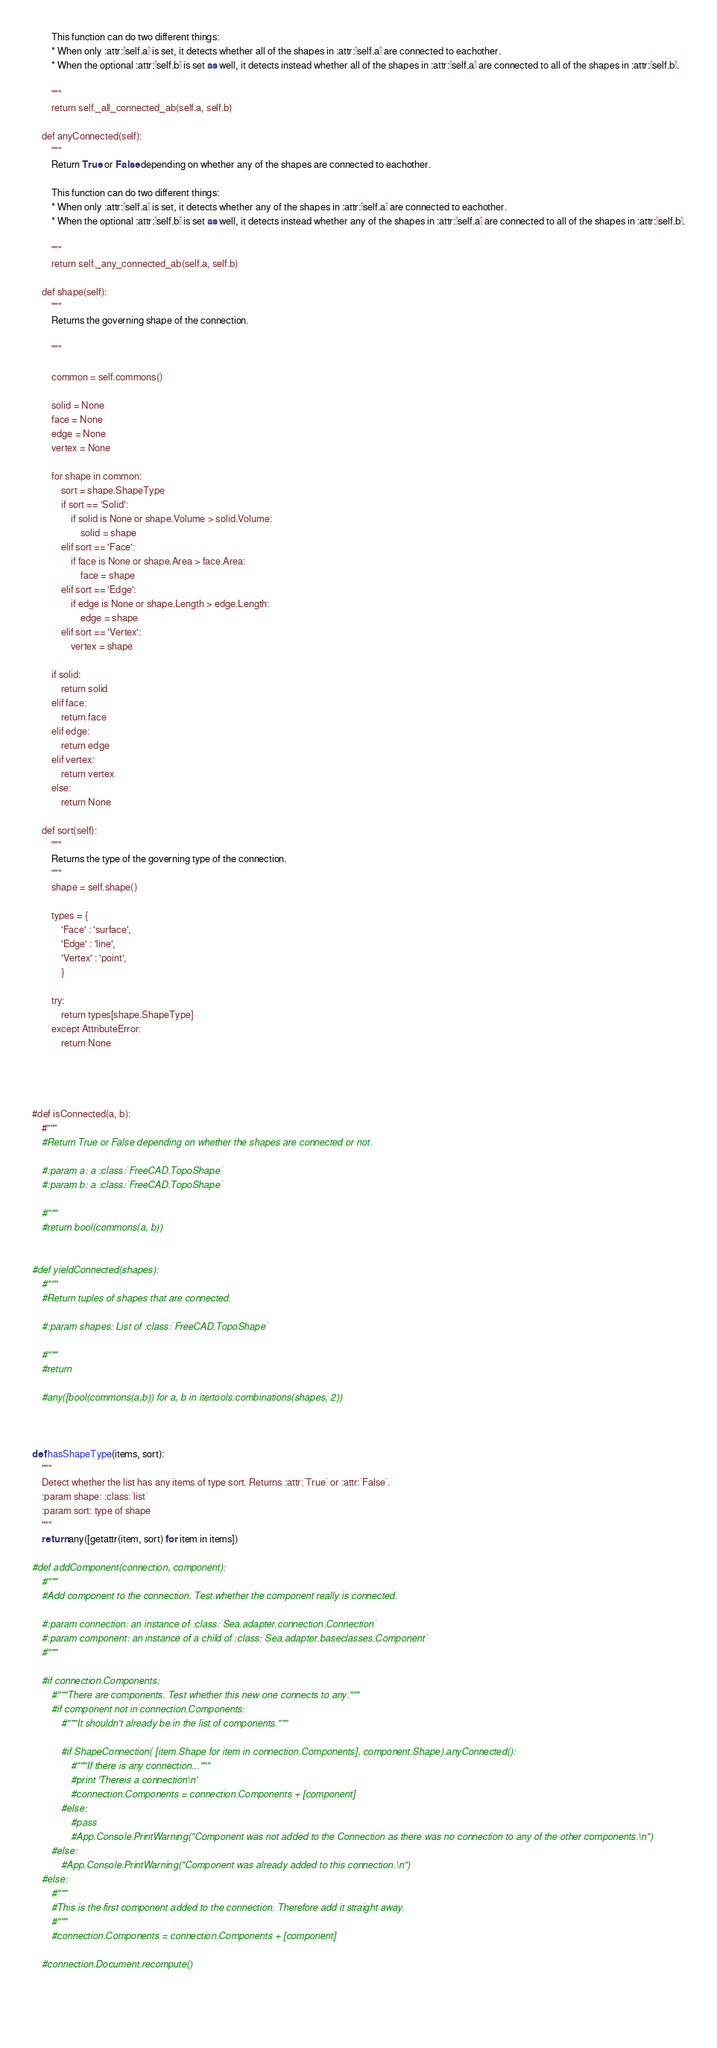<code> <loc_0><loc_0><loc_500><loc_500><_Python_>        This function can do two different things:
        * When only :attr:`self.a` is set, it detects whether all of the shapes in :attr:`self.a` are connected to eachother.
        * When the optional :attr:`self.b` is set as well, it detects instead whether all of the shapes in :attr:`self.a` are connected to all of the shapes in :attr:`self.b`.
        
        """
        return self._all_connected_ab(self.a, self.b)
        
    def anyConnected(self):
        """
        Return True or False depending on whether any of the shapes are connected to eachother.
        
        This function can do two different things:
        * When only :attr:`self.a` is set, it detects whether any of the shapes in :attr:`self.a` are connected to eachother.
        * When the optional :attr:`self.b` is set as well, it detects instead whether any of the shapes in :attr:`self.a` are connected to all of the shapes in :attr:`self.b`.
        
        """
        return self._any_connected_ab(self.a, self.b)
        
    def shape(self):
        """
        Returns the governing shape of the connection.
        
        """
        
        common = self.commons()
        
        solid = None
        face = None
        edge = None
        vertex = None
        
        for shape in common:
            sort = shape.ShapeType
            if sort == 'Solid':
                if solid is None or shape.Volume > solid.Volume:
                    solid = shape
            elif sort == 'Face':
                if face is None or shape.Area > face.Area:
                    face = shape
            elif sort == 'Edge':
                if edge is None or shape.Length > edge.Length:
                    edge = shape
            elif sort == 'Vertex':
                vertex = shape
        
        if solid:
            return solid
        elif face:
            return face
        elif edge:
            return edge
        elif vertex:
            return vertex
        else:
            return None
    
    def sort(self):
        """
        Returns the type of the governing type of the connection.
        """
        shape = self.shape()
        
        types = {
            'Face' : 'surface',
            'Edge' : 'line', 
            'Vertex' : 'point',   
            }
        
        try:
            return types[shape.ShapeType]
        except AttributeError:
            return None
    
        
    
    
#def isConnected(a, b):
    #"""
    #Return True or False depending on whether the shapes are connected or not.
    
    #:param a: a :class:`FreeCAD.TopoShape`
    #:param b: a :class:`FreeCAD.TopoShape`
   
    #"""
    #return bool(commons(a, b))
    

#def yieldConnected(shapes):
    #"""
    #Return tuples of shapes that are connected.
    
    #:param shapes: List of :class:`FreeCAD.TopoShape`
    
    #"""
    #return 
    
    #any([bool(commons(a,b)) for a, b in itertools.combinations(shapes, 2))

    
    
def hasShapeType(items, sort):
    """
    Detect whether the list has any items of type sort. Returns :attr:`True` or :attr:`False`.
    :param shape: :class:`list`
    :param sort: type of shape
    """
    return any([getattr(item, sort) for item in items])
                
#def addComponent(connection, component):
    #"""
    #Add component to the connection. Test whether the component really is connected.
        
    #:param connection: an instance of :class:`Sea.adapter.connection.Connection`
    #:param component: an instance of a child of :class:`Sea.adapter.baseclasses.Component`
    #"""
    
    #if connection.Components:
        #"""There are components. Test whether this new one connects to any."""
        #if component not in connection.Components:
            #"""It shouldn't already be in the list of components."""
            
            #if ShapeConnection( [item.Shape for item in connection.Components], component.Shape).anyConnected():
                #"""If there is any connection..."""
                #print 'Thereis a connection\n'
                #connection.Components = connection.Components + [component]
            #else:
                #pass
                #App.Console.PrintWarning("Component was not added to the Connection as there was no connection to any of the other components.\n")
        #else:
            #App.Console.PrintWarning("Component was already added to this connection.\n")
    #else:
        #"""
        #This is the first component added to the connection. Therefore add it straight away.
        #"""
        #connection.Components = connection.Components + [component]
    
    #connection.Document.recompute()
    
            
    </code> 